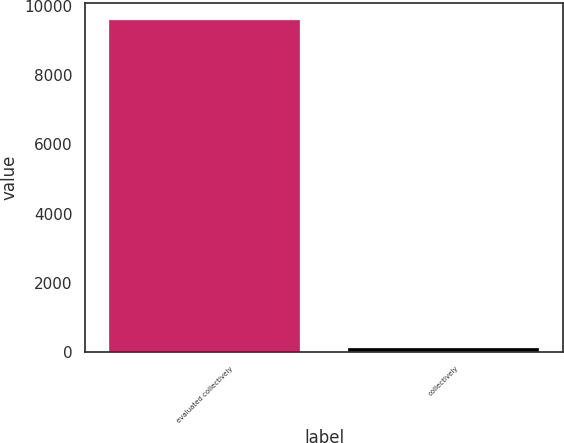<chart> <loc_0><loc_0><loc_500><loc_500><bar_chart><fcel>evaluated collectively<fcel>collectively<nl><fcel>9598.3<fcel>101.2<nl></chart> 